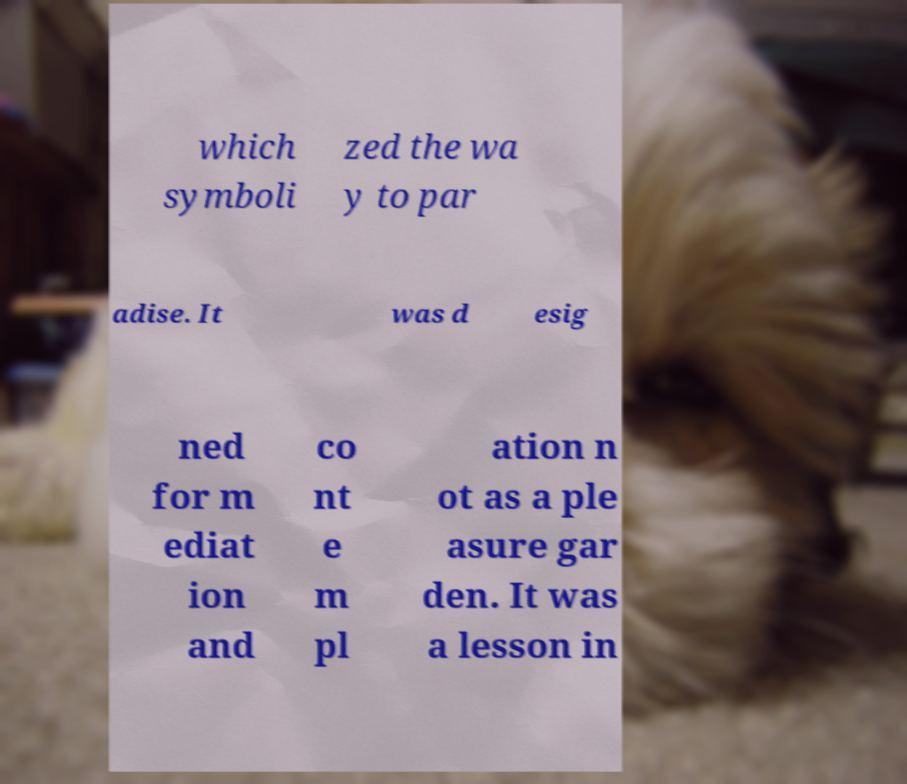Please identify and transcribe the text found in this image. which symboli zed the wa y to par adise. It was d esig ned for m ediat ion and co nt e m pl ation n ot as a ple asure gar den. It was a lesson in 